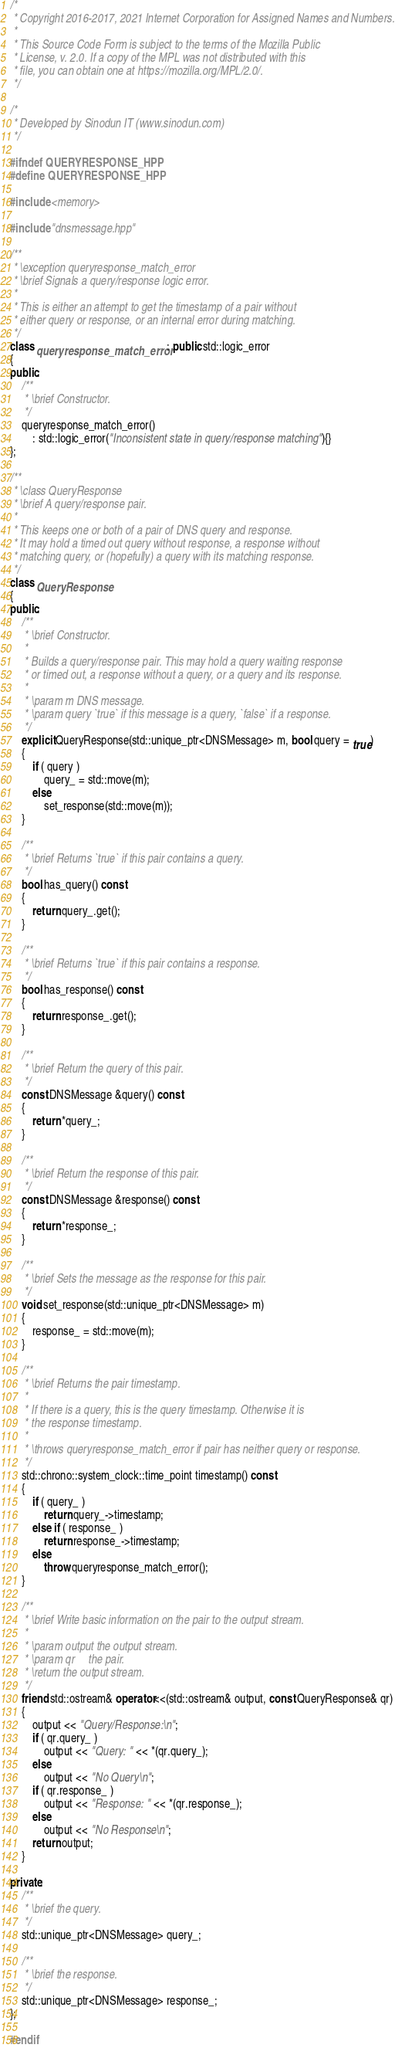<code> <loc_0><loc_0><loc_500><loc_500><_C++_>/*
 * Copyright 2016-2017, 2021 Internet Corporation for Assigned Names and Numbers.
 *
 * This Source Code Form is subject to the terms of the Mozilla Public
 * License, v. 2.0. If a copy of the MPL was not distributed with this
 * file, you can obtain one at https://mozilla.org/MPL/2.0/.
 */

/*
 * Developed by Sinodun IT (www.sinodun.com)
 */

#ifndef QUERYRESPONSE_HPP
#define QUERYRESPONSE_HPP

#include <memory>

#include "dnsmessage.hpp"

/**
 * \exception queryresponse_match_error
 * \brief Signals a query/response logic error.
 *
 * This is either an attempt to get the timestamp of a pair without
 * either query or response, or an internal error during matching.
 */
class queryresponse_match_error : public std::logic_error
{
public:
    /**
     * \brief Constructor.
     */
    queryresponse_match_error()
        : std::logic_error("Inconsistent state in query/response matching"){}
};

/**
 * \class QueryResponse
 * \brief A query/response pair.
 *
 * This keeps one or both of a pair of DNS query and response.
 * It may hold a timed out query without response, a response without
 * matching query, or (hopefully) a query with its matching response.
 */
class QueryResponse
{
public:
    /**
     * \brief Constructor.
     *
     * Builds a query/response pair. This may hold a query waiting response
     * or timed out, a response without a query, or a query and its response.
     *
     * \param m DNS message.
     * \param query `true` if this message is a query, `false` if a response.
     */
    explicit QueryResponse(std::unique_ptr<DNSMessage> m, bool query = true)
    {
        if ( query )
            query_ = std::move(m);
        else
            set_response(std::move(m));
    }

    /**
     * \brief Returns `true` if this pair contains a query.
     */
    bool has_query() const
    {
        return query_.get();
    }

    /**
     * \brief Returns `true` if this pair contains a response.
     */
    bool has_response() const
    {
        return response_.get();
    }

    /**
     * \brief Return the query of this pair.
     */
    const DNSMessage &query() const
    {
        return *query_;
    }

    /**
     * \brief Return the response of this pair.
     */
    const DNSMessage &response() const
    {
        return *response_;
    }

    /**
     * \brief Sets the message as the response for this pair.
     */
    void set_response(std::unique_ptr<DNSMessage> m)
    {
        response_ = std::move(m);
    }

    /**
     * \brief Returns the pair timestamp.
     *
     * If there is a query, this is the query timestamp. Otherwise it is
     * the response timestamp.
     *
     * \throws queryresponse_match_error if pair has neither query or response.
     */
    std::chrono::system_clock::time_point timestamp() const
    {
        if ( query_ )
            return query_->timestamp;
        else if ( response_ )
            return response_->timestamp;
        else
            throw queryresponse_match_error();
    }

    /**
     * \brief Write basic information on the pair to the output stream.
     *
     * \param output the output stream.
     * \param qr     the pair.
     * \return the output stream.
     */
    friend std::ostream& operator<<(std::ostream& output, const QueryResponse& qr)
    {
        output << "Query/Response:\n";
        if ( qr.query_ )
            output << "Query: " << *(qr.query_);
        else
            output << "No Query\n";
        if ( qr.response_ )
            output << "Response: " << *(qr.response_);
        else
            output << "No Response\n";
        return output;
    }

private:
    /**
     * \brief the query.
     */
    std::unique_ptr<DNSMessage> query_;

    /**
     * \brief the response.
     */
    std::unique_ptr<DNSMessage> response_;
};

#endif
</code> 